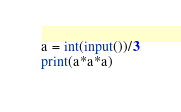<code> <loc_0><loc_0><loc_500><loc_500><_Python_>a = int(input())/3
print(a*a*a)</code> 